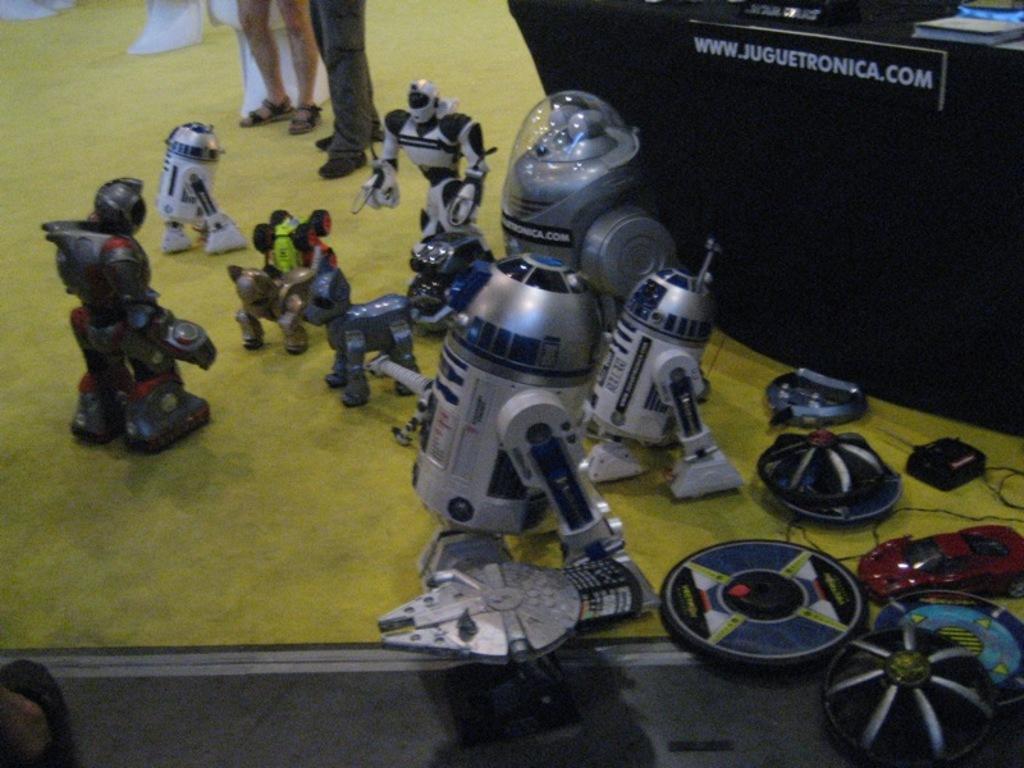Can you describe this image briefly? In the image we can see some toys. Behind the toys we can see a table, on the table we can see some books. At the top of the image we can see some legs. 